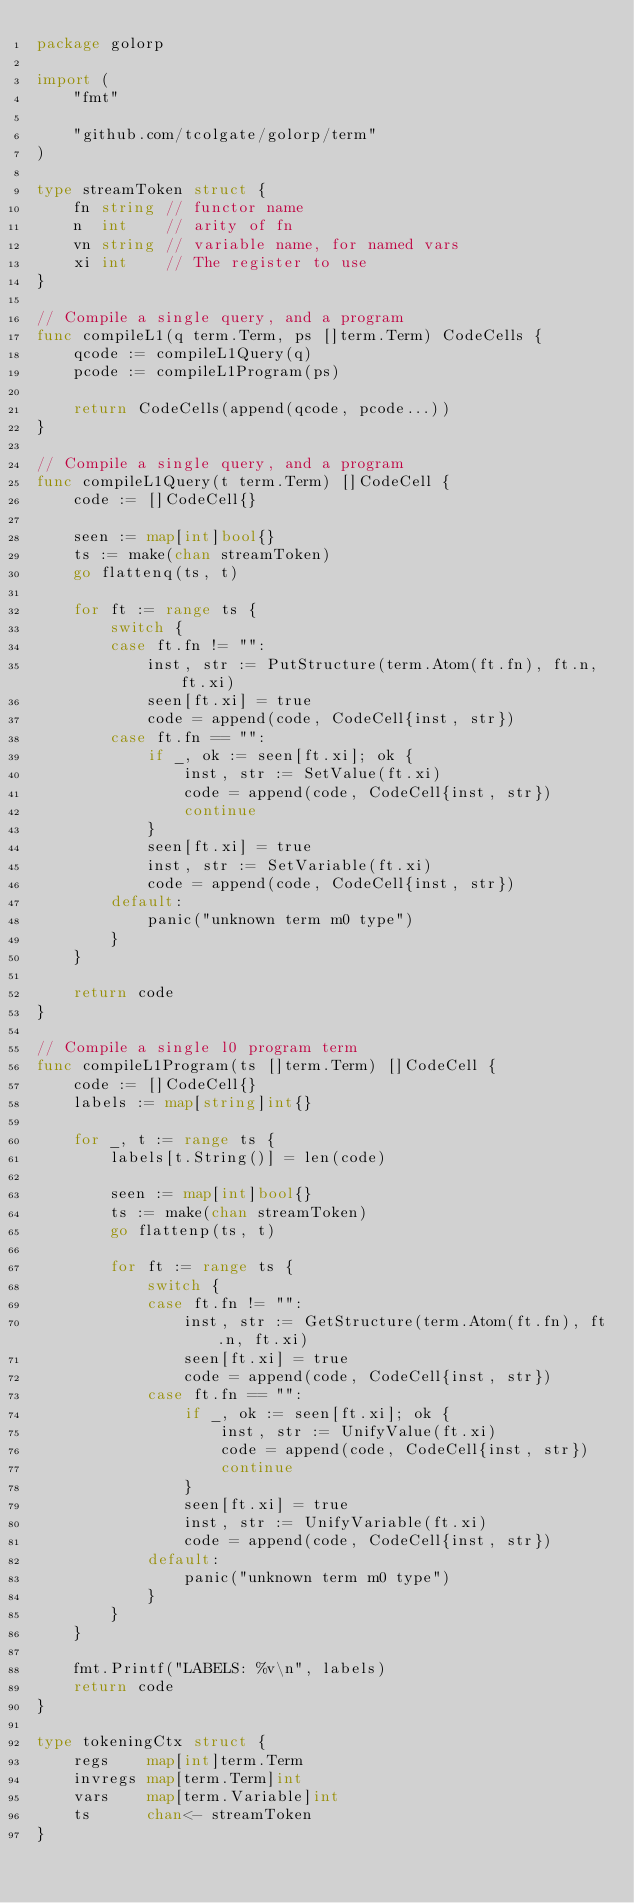Convert code to text. <code><loc_0><loc_0><loc_500><loc_500><_Go_>package golorp

import (
	"fmt"

	"github.com/tcolgate/golorp/term"
)

type streamToken struct {
	fn string // functor name
	n  int    // arity of fn
	vn string // variable name, for named vars
	xi int    // The register to use
}

// Compile a single query, and a program
func compileL1(q term.Term, ps []term.Term) CodeCells {
	qcode := compileL1Query(q)
	pcode := compileL1Program(ps)

	return CodeCells(append(qcode, pcode...))
}

// Compile a single query, and a program
func compileL1Query(t term.Term) []CodeCell {
	code := []CodeCell{}

	seen := map[int]bool{}
	ts := make(chan streamToken)
	go flattenq(ts, t)

	for ft := range ts {
		switch {
		case ft.fn != "":
			inst, str := PutStructure(term.Atom(ft.fn), ft.n, ft.xi)
			seen[ft.xi] = true
			code = append(code, CodeCell{inst, str})
		case ft.fn == "":
			if _, ok := seen[ft.xi]; ok {
				inst, str := SetValue(ft.xi)
				code = append(code, CodeCell{inst, str})
				continue
			}
			seen[ft.xi] = true
			inst, str := SetVariable(ft.xi)
			code = append(code, CodeCell{inst, str})
		default:
			panic("unknown term m0 type")
		}
	}

	return code
}

// Compile a single l0 program term
func compileL1Program(ts []term.Term) []CodeCell {
	code := []CodeCell{}
	labels := map[string]int{}

	for _, t := range ts {
		labels[t.String()] = len(code)

		seen := map[int]bool{}
		ts := make(chan streamToken)
		go flattenp(ts, t)

		for ft := range ts {
			switch {
			case ft.fn != "":
				inst, str := GetStructure(term.Atom(ft.fn), ft.n, ft.xi)
				seen[ft.xi] = true
				code = append(code, CodeCell{inst, str})
			case ft.fn == "":
				if _, ok := seen[ft.xi]; ok {
					inst, str := UnifyValue(ft.xi)
					code = append(code, CodeCell{inst, str})
					continue
				}
				seen[ft.xi] = true
				inst, str := UnifyVariable(ft.xi)
				code = append(code, CodeCell{inst, str})
			default:
				panic("unknown term m0 type")
			}
		}
	}

	fmt.Printf("LABELS: %v\n", labels)
	return code
}

type tokeningCtx struct {
	regs    map[int]term.Term
	invregs map[term.Term]int
	vars    map[term.Variable]int
	ts      chan<- streamToken
}
</code> 